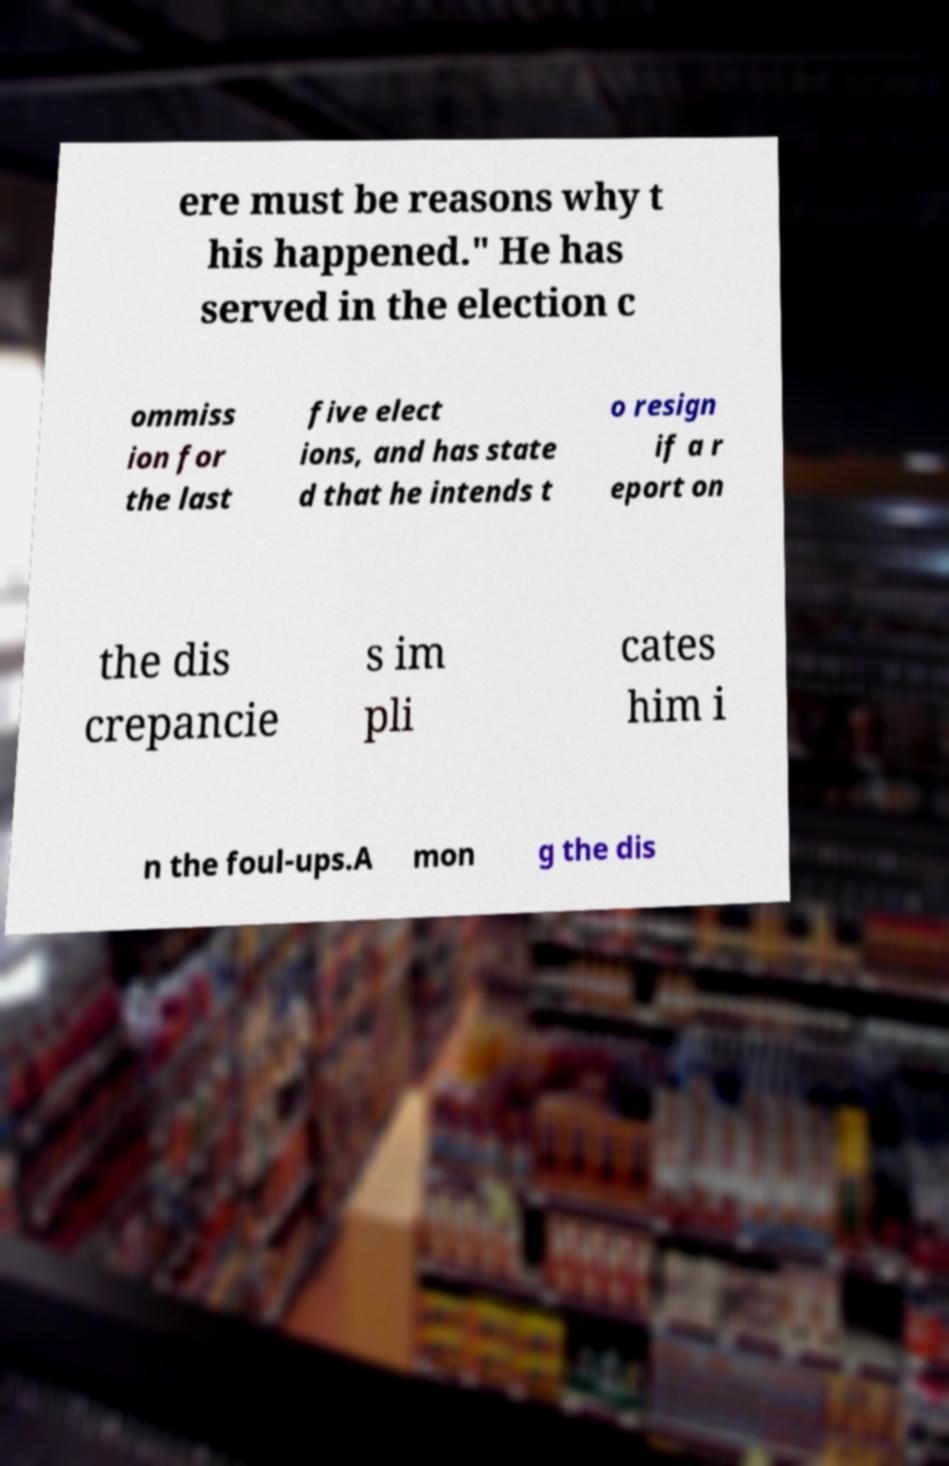Please read and relay the text visible in this image. What does it say? ere must be reasons why t his happened." He has served in the election c ommiss ion for the last five elect ions, and has state d that he intends t o resign if a r eport on the dis crepancie s im pli cates him i n the foul-ups.A mon g the dis 